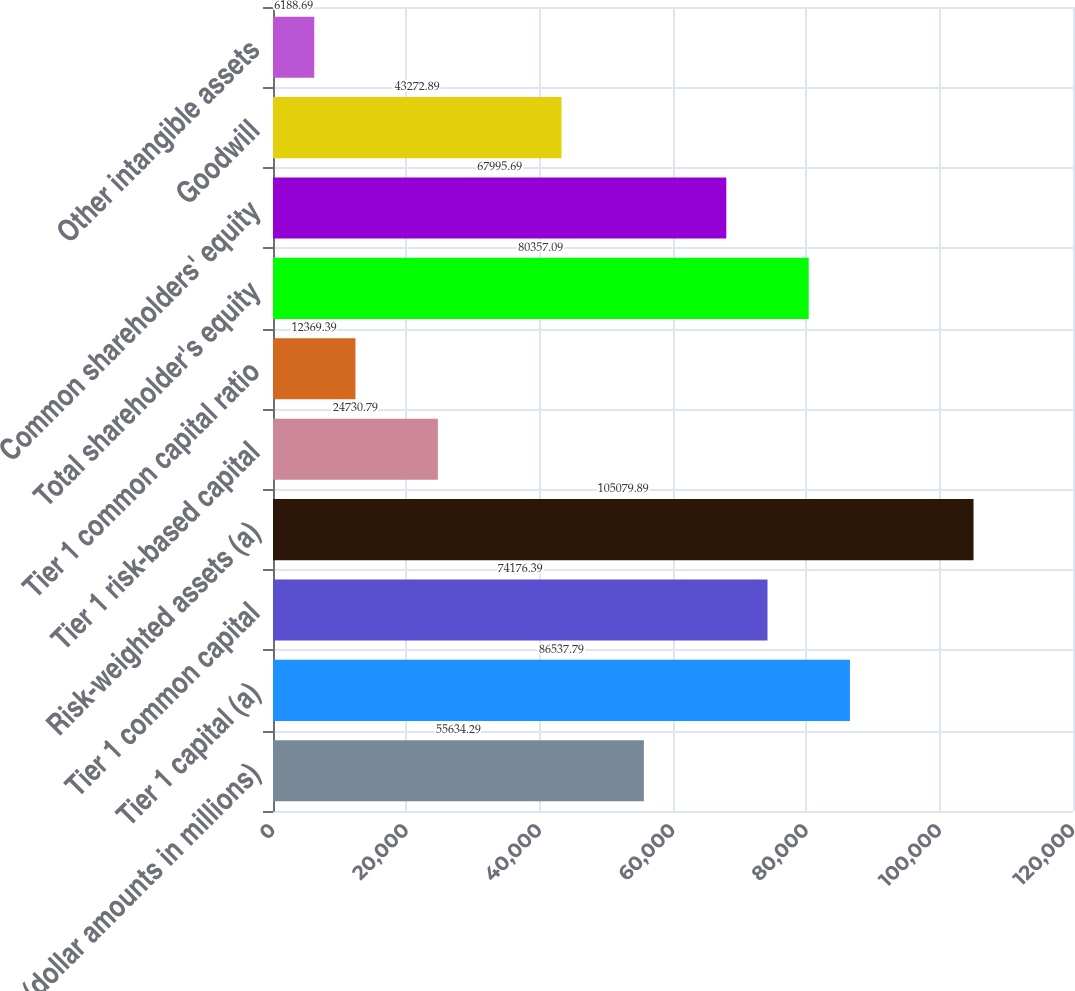Convert chart to OTSL. <chart><loc_0><loc_0><loc_500><loc_500><bar_chart><fcel>(dollar amounts in millions)<fcel>Tier 1 capital (a)<fcel>Tier 1 common capital<fcel>Risk-weighted assets (a)<fcel>Tier 1 risk-based capital<fcel>Tier 1 common capital ratio<fcel>Total shareholder's equity<fcel>Common shareholders' equity<fcel>Goodwill<fcel>Other intangible assets<nl><fcel>55634.3<fcel>86537.8<fcel>74176.4<fcel>105080<fcel>24730.8<fcel>12369.4<fcel>80357.1<fcel>67995.7<fcel>43272.9<fcel>6188.69<nl></chart> 